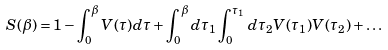Convert formula to latex. <formula><loc_0><loc_0><loc_500><loc_500>S ( \beta ) = 1 - \int _ { 0 } ^ { \beta } V ( \tau ) d \tau + \int _ { 0 } ^ { \beta } d \tau _ { 1 } \int _ { 0 } ^ { \tau _ { 1 } } d \tau _ { 2 } V ( \tau _ { 1 } ) V ( \tau _ { 2 } ) + \dots</formula> 